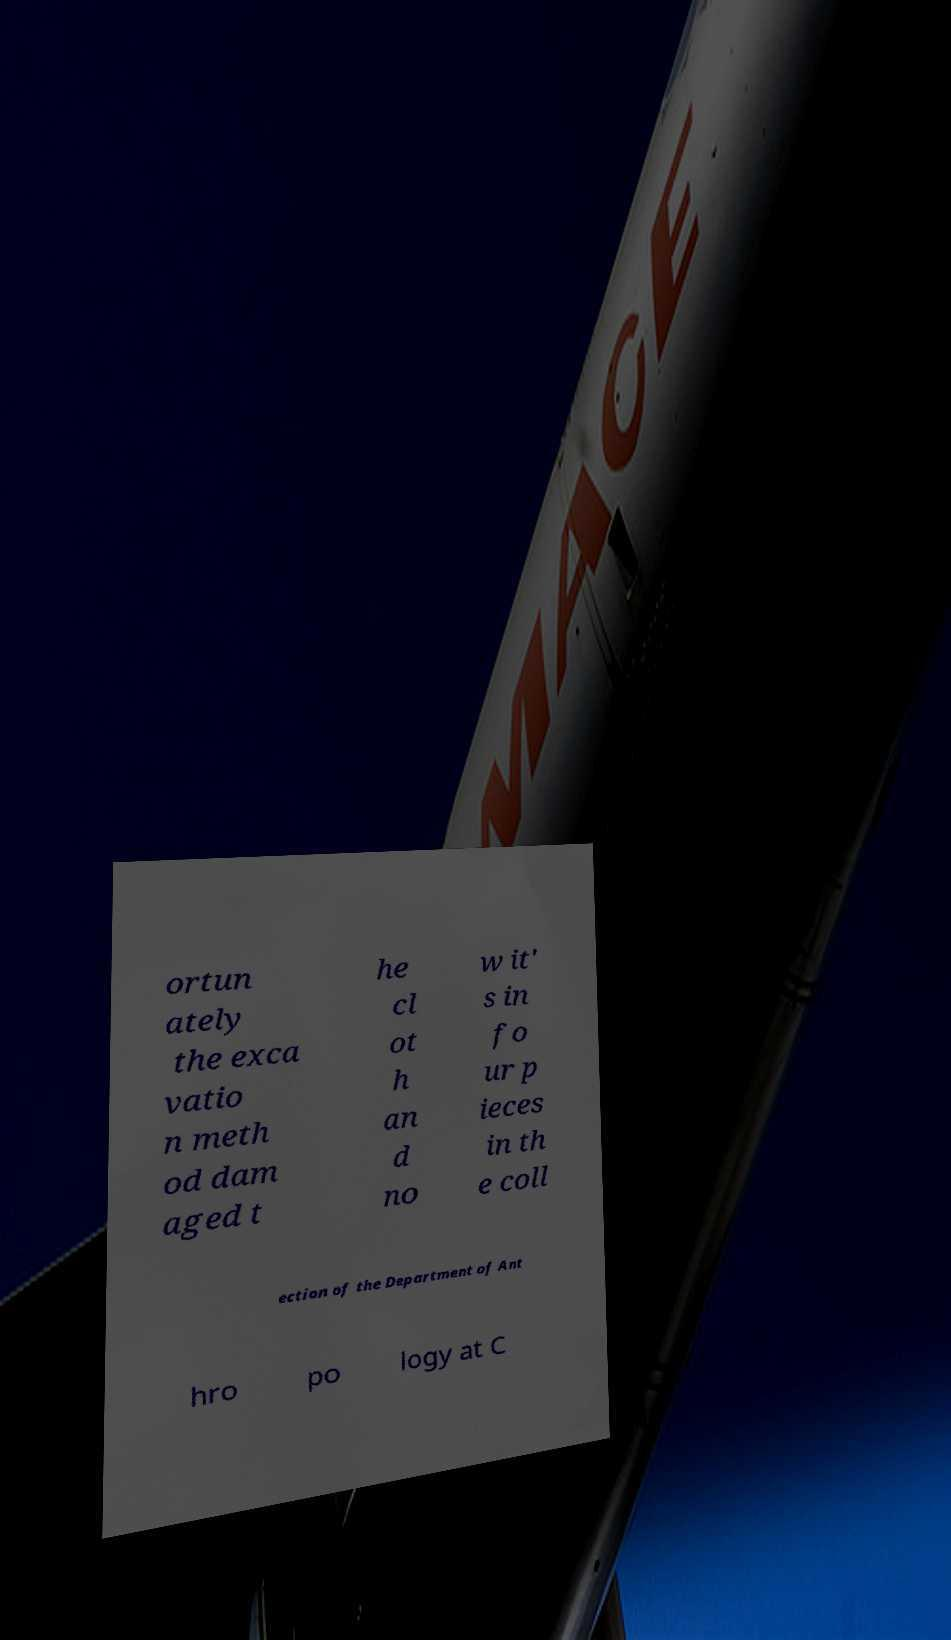Can you read and provide the text displayed in the image?This photo seems to have some interesting text. Can you extract and type it out for me? ortun ately the exca vatio n meth od dam aged t he cl ot h an d no w it' s in fo ur p ieces in th e coll ection of the Department of Ant hro po logy at C 